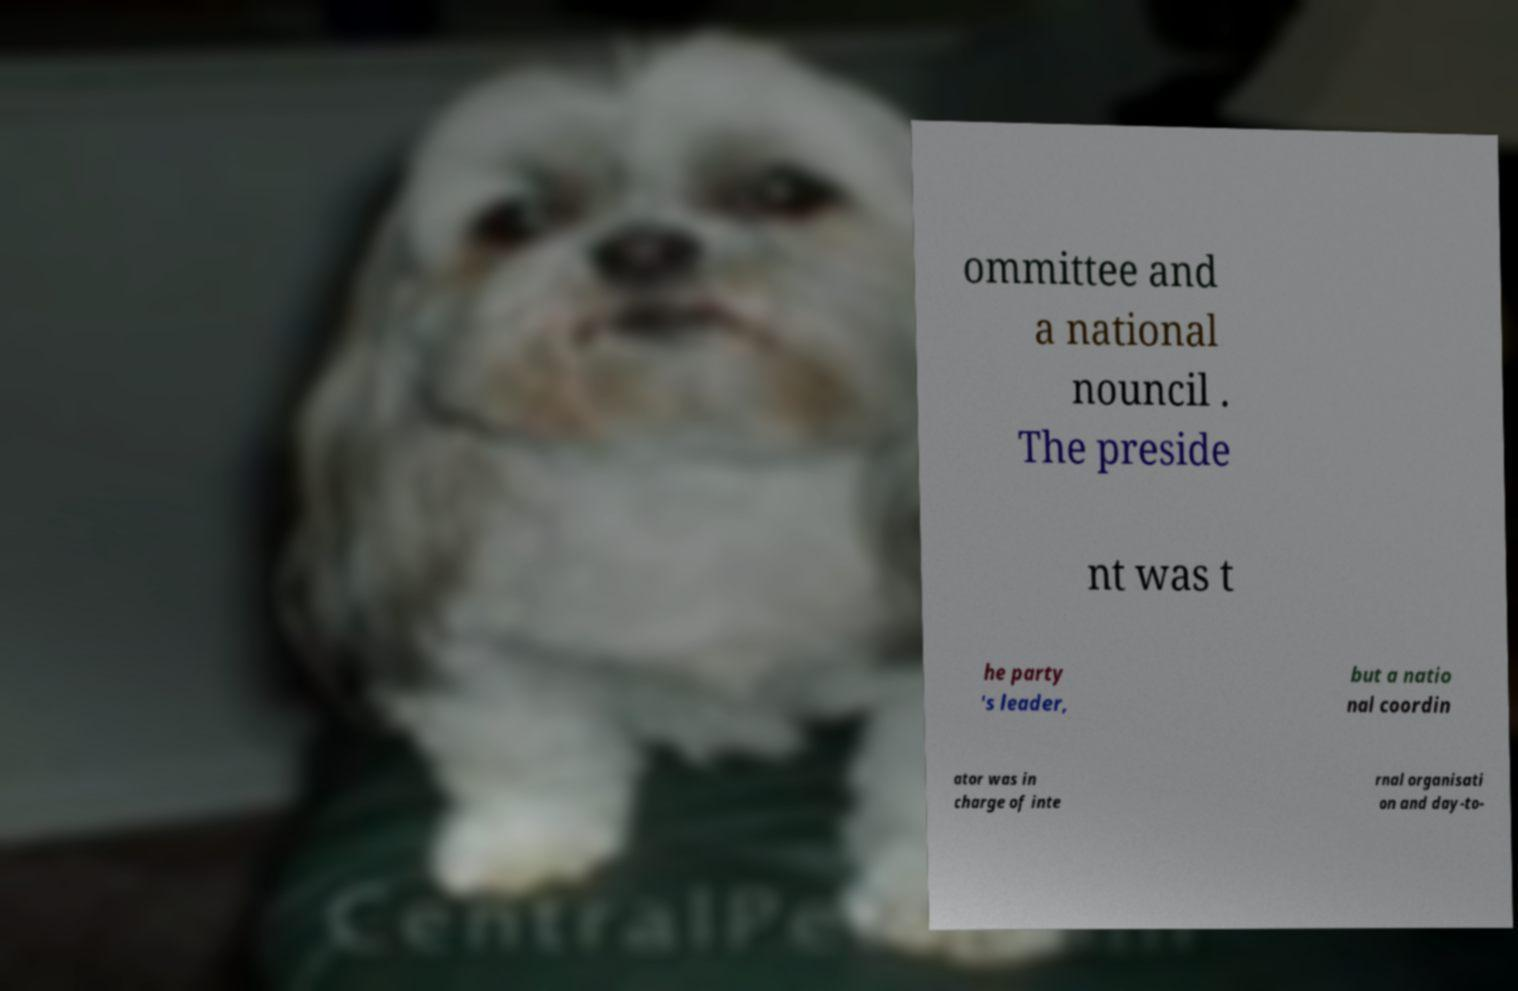Could you assist in decoding the text presented in this image and type it out clearly? ommittee and a national nouncil . The preside nt was t he party 's leader, but a natio nal coordin ator was in charge of inte rnal organisati on and day-to- 